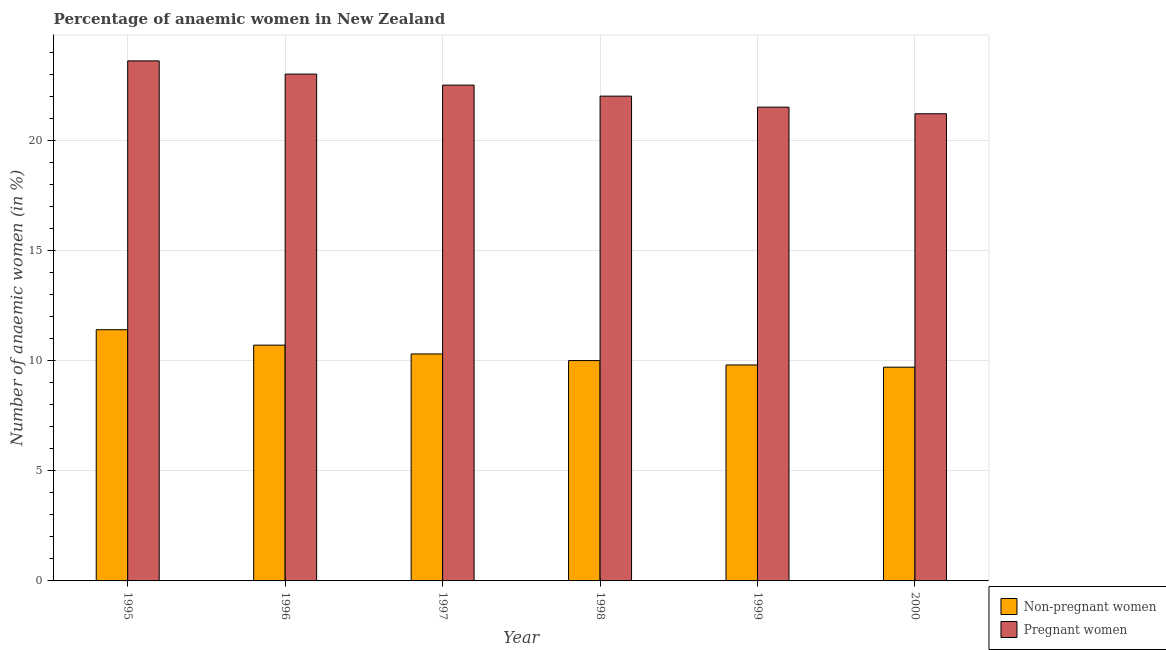How many different coloured bars are there?
Give a very brief answer. 2. How many bars are there on the 4th tick from the right?
Keep it short and to the point. 2. What is the label of the 3rd group of bars from the left?
Your answer should be very brief. 1997. In how many cases, is the number of bars for a given year not equal to the number of legend labels?
Offer a very short reply. 0. What is the percentage of pregnant anaemic women in 1996?
Give a very brief answer. 23. Across all years, what is the maximum percentage of pregnant anaemic women?
Keep it short and to the point. 23.6. Across all years, what is the minimum percentage of non-pregnant anaemic women?
Provide a succinct answer. 9.7. In which year was the percentage of non-pregnant anaemic women minimum?
Offer a terse response. 2000. What is the total percentage of pregnant anaemic women in the graph?
Your answer should be compact. 133.8. What is the difference between the percentage of non-pregnant anaemic women in 1996 and that in 1998?
Ensure brevity in your answer.  0.7. What is the difference between the percentage of pregnant anaemic women in 2000 and the percentage of non-pregnant anaemic women in 1998?
Your response must be concise. -0.8. What is the average percentage of non-pregnant anaemic women per year?
Make the answer very short. 10.32. In the year 1998, what is the difference between the percentage of pregnant anaemic women and percentage of non-pregnant anaemic women?
Your answer should be very brief. 0. In how many years, is the percentage of pregnant anaemic women greater than 19 %?
Your answer should be compact. 6. What is the ratio of the percentage of non-pregnant anaemic women in 1996 to that in 2000?
Your answer should be very brief. 1.1. What is the difference between the highest and the second highest percentage of pregnant anaemic women?
Ensure brevity in your answer.  0.6. What is the difference between the highest and the lowest percentage of non-pregnant anaemic women?
Keep it short and to the point. 1.7. In how many years, is the percentage of non-pregnant anaemic women greater than the average percentage of non-pregnant anaemic women taken over all years?
Offer a very short reply. 2. Is the sum of the percentage of non-pregnant anaemic women in 1998 and 1999 greater than the maximum percentage of pregnant anaemic women across all years?
Make the answer very short. Yes. What does the 2nd bar from the left in 1998 represents?
Offer a very short reply. Pregnant women. What does the 2nd bar from the right in 1996 represents?
Keep it short and to the point. Non-pregnant women. How many bars are there?
Make the answer very short. 12. Are all the bars in the graph horizontal?
Your answer should be compact. No. How many years are there in the graph?
Offer a very short reply. 6. Does the graph contain any zero values?
Your answer should be very brief. No. Does the graph contain grids?
Your response must be concise. Yes. Where does the legend appear in the graph?
Provide a succinct answer. Bottom right. How many legend labels are there?
Offer a terse response. 2. How are the legend labels stacked?
Your answer should be compact. Vertical. What is the title of the graph?
Provide a short and direct response. Percentage of anaemic women in New Zealand. What is the label or title of the Y-axis?
Your response must be concise. Number of anaemic women (in %). What is the Number of anaemic women (in %) of Non-pregnant women in 1995?
Ensure brevity in your answer.  11.4. What is the Number of anaemic women (in %) in Pregnant women in 1995?
Ensure brevity in your answer.  23.6. What is the Number of anaemic women (in %) of Non-pregnant women in 1996?
Ensure brevity in your answer.  10.7. What is the Number of anaemic women (in %) of Pregnant women in 1997?
Keep it short and to the point. 22.5. What is the Number of anaemic women (in %) of Non-pregnant women in 1998?
Give a very brief answer. 10. What is the Number of anaemic women (in %) in Pregnant women in 1998?
Ensure brevity in your answer.  22. What is the Number of anaemic women (in %) of Pregnant women in 2000?
Provide a succinct answer. 21.2. Across all years, what is the maximum Number of anaemic women (in %) in Pregnant women?
Make the answer very short. 23.6. Across all years, what is the minimum Number of anaemic women (in %) in Pregnant women?
Provide a succinct answer. 21.2. What is the total Number of anaemic women (in %) in Non-pregnant women in the graph?
Offer a very short reply. 61.9. What is the total Number of anaemic women (in %) of Pregnant women in the graph?
Offer a very short reply. 133.8. What is the difference between the Number of anaemic women (in %) of Non-pregnant women in 1995 and that in 1996?
Make the answer very short. 0.7. What is the difference between the Number of anaemic women (in %) of Pregnant women in 1995 and that in 1996?
Ensure brevity in your answer.  0.6. What is the difference between the Number of anaemic women (in %) in Pregnant women in 1995 and that in 1997?
Ensure brevity in your answer.  1.1. What is the difference between the Number of anaemic women (in %) in Pregnant women in 1995 and that in 1998?
Keep it short and to the point. 1.6. What is the difference between the Number of anaemic women (in %) in Non-pregnant women in 1995 and that in 1999?
Offer a terse response. 1.6. What is the difference between the Number of anaemic women (in %) in Pregnant women in 1995 and that in 1999?
Provide a succinct answer. 2.1. What is the difference between the Number of anaemic women (in %) in Non-pregnant women in 1995 and that in 2000?
Ensure brevity in your answer.  1.7. What is the difference between the Number of anaemic women (in %) in Pregnant women in 1995 and that in 2000?
Make the answer very short. 2.4. What is the difference between the Number of anaemic women (in %) in Non-pregnant women in 1996 and that in 1997?
Keep it short and to the point. 0.4. What is the difference between the Number of anaemic women (in %) in Pregnant women in 1996 and that in 1997?
Ensure brevity in your answer.  0.5. What is the difference between the Number of anaemic women (in %) of Pregnant women in 1996 and that in 1999?
Provide a succinct answer. 1.5. What is the difference between the Number of anaemic women (in %) in Non-pregnant women in 1996 and that in 2000?
Make the answer very short. 1. What is the difference between the Number of anaemic women (in %) in Pregnant women in 1997 and that in 1998?
Offer a terse response. 0.5. What is the difference between the Number of anaemic women (in %) of Pregnant women in 1997 and that in 1999?
Give a very brief answer. 1. What is the difference between the Number of anaemic women (in %) in Pregnant women in 1997 and that in 2000?
Offer a very short reply. 1.3. What is the difference between the Number of anaemic women (in %) in Pregnant women in 1998 and that in 1999?
Ensure brevity in your answer.  0.5. What is the difference between the Number of anaemic women (in %) of Non-pregnant women in 1998 and that in 2000?
Your response must be concise. 0.3. What is the difference between the Number of anaemic women (in %) of Pregnant women in 1999 and that in 2000?
Keep it short and to the point. 0.3. What is the difference between the Number of anaemic women (in %) in Non-pregnant women in 1995 and the Number of anaemic women (in %) in Pregnant women in 1999?
Offer a terse response. -10.1. What is the difference between the Number of anaemic women (in %) in Non-pregnant women in 1996 and the Number of anaemic women (in %) in Pregnant women in 1999?
Make the answer very short. -10.8. What is the difference between the Number of anaemic women (in %) of Non-pregnant women in 1997 and the Number of anaemic women (in %) of Pregnant women in 1998?
Your answer should be very brief. -11.7. What is the difference between the Number of anaemic women (in %) in Non-pregnant women in 1998 and the Number of anaemic women (in %) in Pregnant women in 1999?
Offer a terse response. -11.5. What is the difference between the Number of anaemic women (in %) in Non-pregnant women in 1999 and the Number of anaemic women (in %) in Pregnant women in 2000?
Offer a very short reply. -11.4. What is the average Number of anaemic women (in %) of Non-pregnant women per year?
Give a very brief answer. 10.32. What is the average Number of anaemic women (in %) in Pregnant women per year?
Offer a terse response. 22.3. In the year 1995, what is the difference between the Number of anaemic women (in %) in Non-pregnant women and Number of anaemic women (in %) in Pregnant women?
Your answer should be compact. -12.2. In the year 1996, what is the difference between the Number of anaemic women (in %) of Non-pregnant women and Number of anaemic women (in %) of Pregnant women?
Provide a succinct answer. -12.3. In the year 1997, what is the difference between the Number of anaemic women (in %) of Non-pregnant women and Number of anaemic women (in %) of Pregnant women?
Ensure brevity in your answer.  -12.2. In the year 2000, what is the difference between the Number of anaemic women (in %) in Non-pregnant women and Number of anaemic women (in %) in Pregnant women?
Make the answer very short. -11.5. What is the ratio of the Number of anaemic women (in %) in Non-pregnant women in 1995 to that in 1996?
Your response must be concise. 1.07. What is the ratio of the Number of anaemic women (in %) of Pregnant women in 1995 to that in 1996?
Make the answer very short. 1.03. What is the ratio of the Number of anaemic women (in %) in Non-pregnant women in 1995 to that in 1997?
Your response must be concise. 1.11. What is the ratio of the Number of anaemic women (in %) of Pregnant women in 1995 to that in 1997?
Give a very brief answer. 1.05. What is the ratio of the Number of anaemic women (in %) of Non-pregnant women in 1995 to that in 1998?
Make the answer very short. 1.14. What is the ratio of the Number of anaemic women (in %) of Pregnant women in 1995 to that in 1998?
Provide a succinct answer. 1.07. What is the ratio of the Number of anaemic women (in %) of Non-pregnant women in 1995 to that in 1999?
Keep it short and to the point. 1.16. What is the ratio of the Number of anaemic women (in %) in Pregnant women in 1995 to that in 1999?
Your response must be concise. 1.1. What is the ratio of the Number of anaemic women (in %) in Non-pregnant women in 1995 to that in 2000?
Your answer should be very brief. 1.18. What is the ratio of the Number of anaemic women (in %) of Pregnant women in 1995 to that in 2000?
Your response must be concise. 1.11. What is the ratio of the Number of anaemic women (in %) of Non-pregnant women in 1996 to that in 1997?
Give a very brief answer. 1.04. What is the ratio of the Number of anaemic women (in %) of Pregnant women in 1996 to that in 1997?
Keep it short and to the point. 1.02. What is the ratio of the Number of anaemic women (in %) in Non-pregnant women in 1996 to that in 1998?
Offer a terse response. 1.07. What is the ratio of the Number of anaemic women (in %) of Pregnant women in 1996 to that in 1998?
Your response must be concise. 1.05. What is the ratio of the Number of anaemic women (in %) of Non-pregnant women in 1996 to that in 1999?
Offer a very short reply. 1.09. What is the ratio of the Number of anaemic women (in %) of Pregnant women in 1996 to that in 1999?
Provide a succinct answer. 1.07. What is the ratio of the Number of anaemic women (in %) in Non-pregnant women in 1996 to that in 2000?
Your answer should be compact. 1.1. What is the ratio of the Number of anaemic women (in %) of Pregnant women in 1996 to that in 2000?
Provide a short and direct response. 1.08. What is the ratio of the Number of anaemic women (in %) of Pregnant women in 1997 to that in 1998?
Your answer should be compact. 1.02. What is the ratio of the Number of anaemic women (in %) in Non-pregnant women in 1997 to that in 1999?
Offer a terse response. 1.05. What is the ratio of the Number of anaemic women (in %) in Pregnant women in 1997 to that in 1999?
Your response must be concise. 1.05. What is the ratio of the Number of anaemic women (in %) of Non-pregnant women in 1997 to that in 2000?
Offer a terse response. 1.06. What is the ratio of the Number of anaemic women (in %) of Pregnant women in 1997 to that in 2000?
Provide a short and direct response. 1.06. What is the ratio of the Number of anaemic women (in %) in Non-pregnant women in 1998 to that in 1999?
Make the answer very short. 1.02. What is the ratio of the Number of anaemic women (in %) of Pregnant women in 1998 to that in 1999?
Make the answer very short. 1.02. What is the ratio of the Number of anaemic women (in %) in Non-pregnant women in 1998 to that in 2000?
Make the answer very short. 1.03. What is the ratio of the Number of anaemic women (in %) in Pregnant women in 1998 to that in 2000?
Offer a terse response. 1.04. What is the ratio of the Number of anaemic women (in %) of Non-pregnant women in 1999 to that in 2000?
Give a very brief answer. 1.01. What is the ratio of the Number of anaemic women (in %) in Pregnant women in 1999 to that in 2000?
Your response must be concise. 1.01. What is the difference between the highest and the lowest Number of anaemic women (in %) in Pregnant women?
Your answer should be compact. 2.4. 